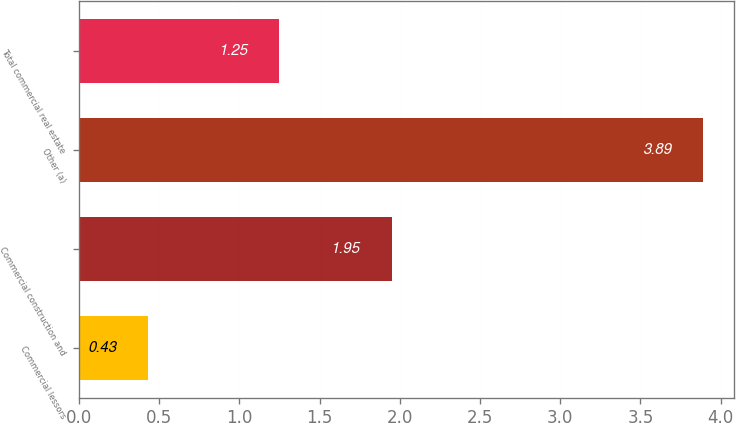Convert chart to OTSL. <chart><loc_0><loc_0><loc_500><loc_500><bar_chart><fcel>Commercial lessors<fcel>Commercial construction and<fcel>Other (a)<fcel>Total commercial real estate<nl><fcel>0.43<fcel>1.95<fcel>3.89<fcel>1.25<nl></chart> 